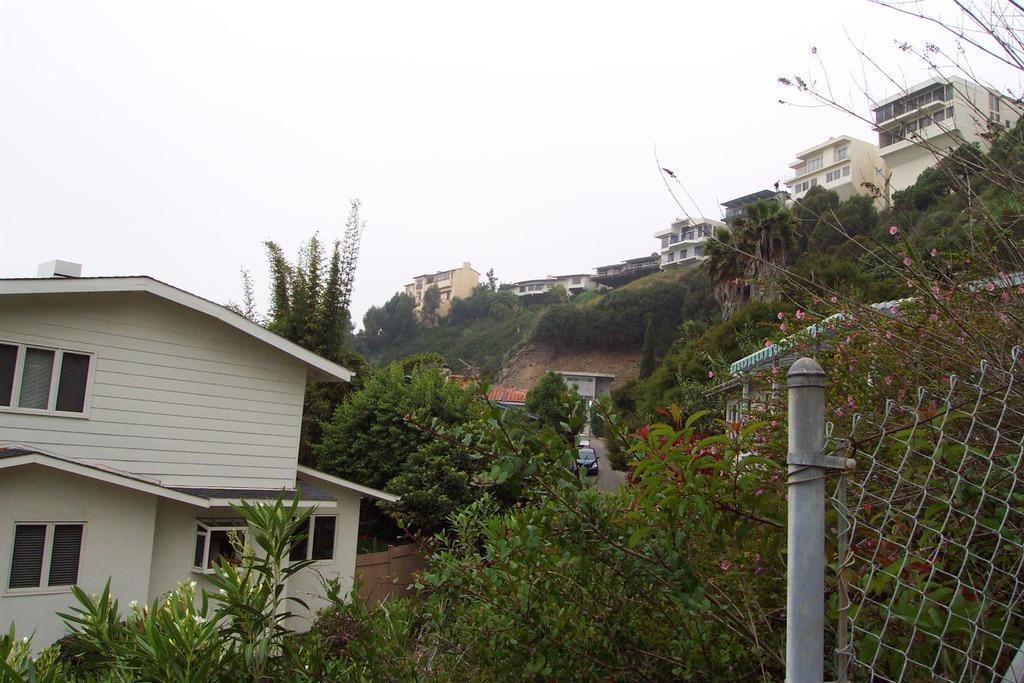In one or two sentences, can you explain what this image depicts? On the right side of the image there is a metal fence. In the center of the image there is a car on the road. In the background of the image there are plants, trees, buildings and sky. 